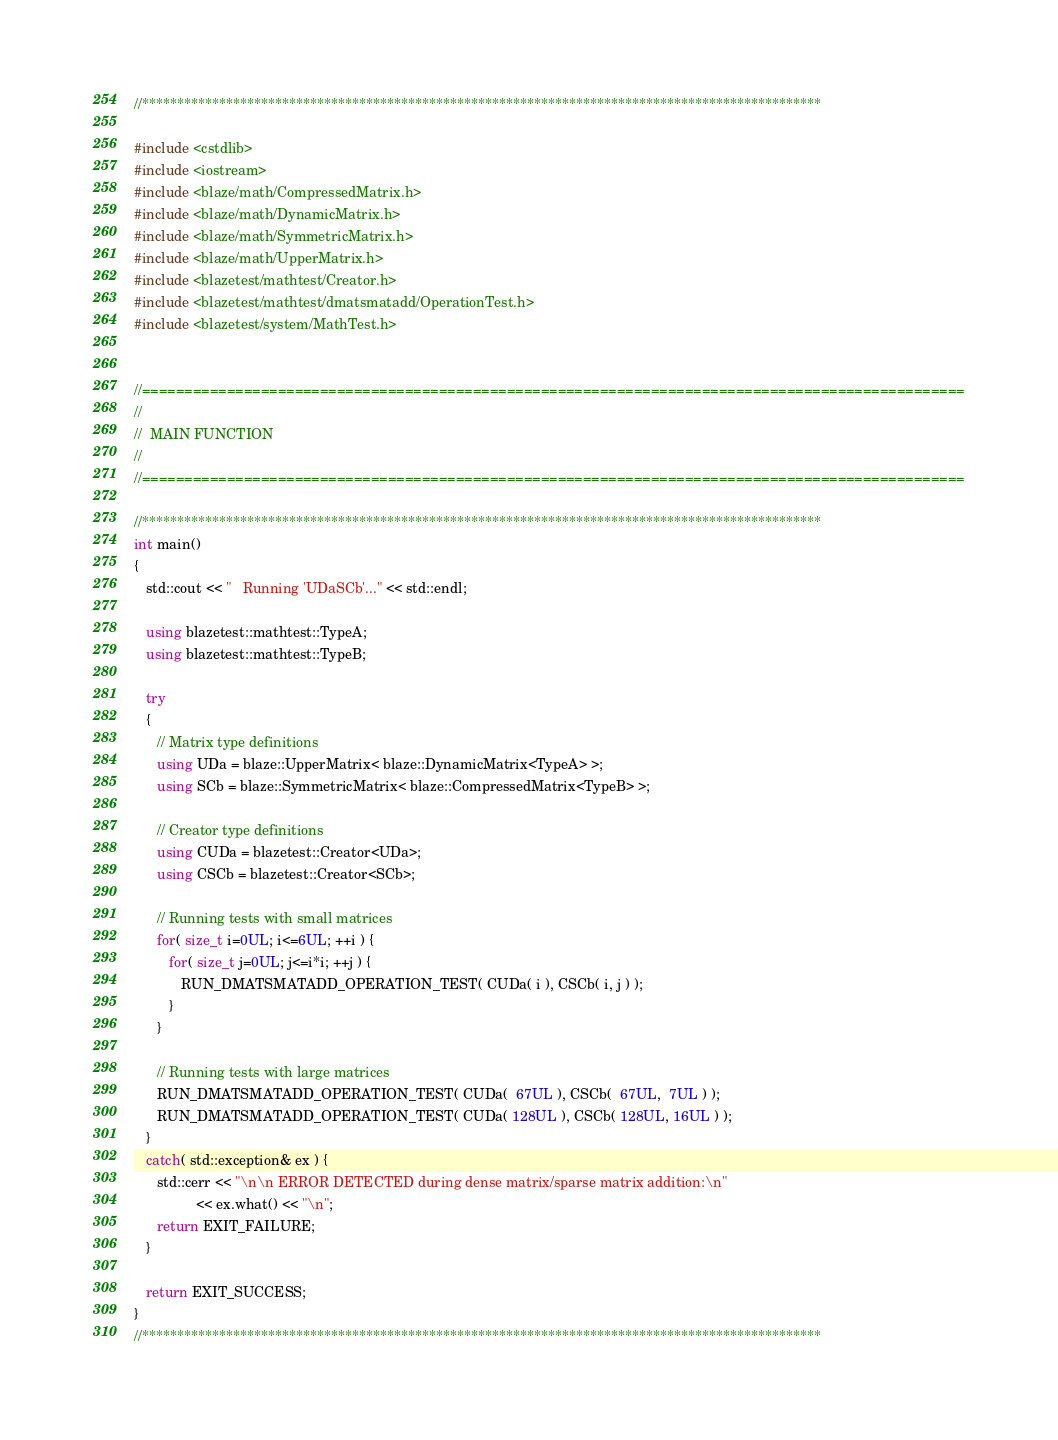<code> <loc_0><loc_0><loc_500><loc_500><_C++_>//*************************************************************************************************

#include <cstdlib>
#include <iostream>
#include <blaze/math/CompressedMatrix.h>
#include <blaze/math/DynamicMatrix.h>
#include <blaze/math/SymmetricMatrix.h>
#include <blaze/math/UpperMatrix.h>
#include <blazetest/mathtest/Creator.h>
#include <blazetest/mathtest/dmatsmatadd/OperationTest.h>
#include <blazetest/system/MathTest.h>


//=================================================================================================
//
//  MAIN FUNCTION
//
//=================================================================================================

//*************************************************************************************************
int main()
{
   std::cout << "   Running 'UDaSCb'..." << std::endl;

   using blazetest::mathtest::TypeA;
   using blazetest::mathtest::TypeB;

   try
   {
      // Matrix type definitions
      using UDa = blaze::UpperMatrix< blaze::DynamicMatrix<TypeA> >;
      using SCb = blaze::SymmetricMatrix< blaze::CompressedMatrix<TypeB> >;

      // Creator type definitions
      using CUDa = blazetest::Creator<UDa>;
      using CSCb = blazetest::Creator<SCb>;

      // Running tests with small matrices
      for( size_t i=0UL; i<=6UL; ++i ) {
         for( size_t j=0UL; j<=i*i; ++j ) {
            RUN_DMATSMATADD_OPERATION_TEST( CUDa( i ), CSCb( i, j ) );
         }
      }

      // Running tests with large matrices
      RUN_DMATSMATADD_OPERATION_TEST( CUDa(  67UL ), CSCb(  67UL,  7UL ) );
      RUN_DMATSMATADD_OPERATION_TEST( CUDa( 128UL ), CSCb( 128UL, 16UL ) );
   }
   catch( std::exception& ex ) {
      std::cerr << "\n\n ERROR DETECTED during dense matrix/sparse matrix addition:\n"
                << ex.what() << "\n";
      return EXIT_FAILURE;
   }

   return EXIT_SUCCESS;
}
//*************************************************************************************************
</code> 